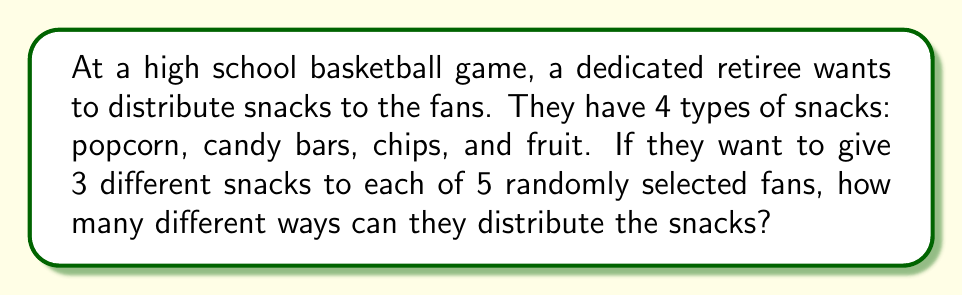Teach me how to tackle this problem. Let's approach this step-by-step:

1) First, we need to understand what the question is asking. We're selecting 3 snacks out of 4 types for each of 5 fans.

2) For each fan, we're making a selection of 3 snacks out of 4 without repetition and where the order doesn't matter. This is a combination problem.

3) The number of ways to select 3 items out of 4 is denoted as $\binom{4}{3}$ or $C(4,3)$, and is calculated as:

   $$\binom{4}{3} = \frac{4!}{3!(4-3)!} = \frac{4!}{3!1!} = 4$$

4) Now, we need to make this selection for each of the 5 fans independently. When we have independent events, we multiply the number of possibilities.

5) Therefore, the total number of ways to distribute the snacks is:

   $$4^5 = 4 \times 4 \times 4 \times 4 \times 4 = 1024$$

This means there are 1024 different ways the retiree can distribute 3 different snacks to each of 5 fans.
Answer: 1024 ways 